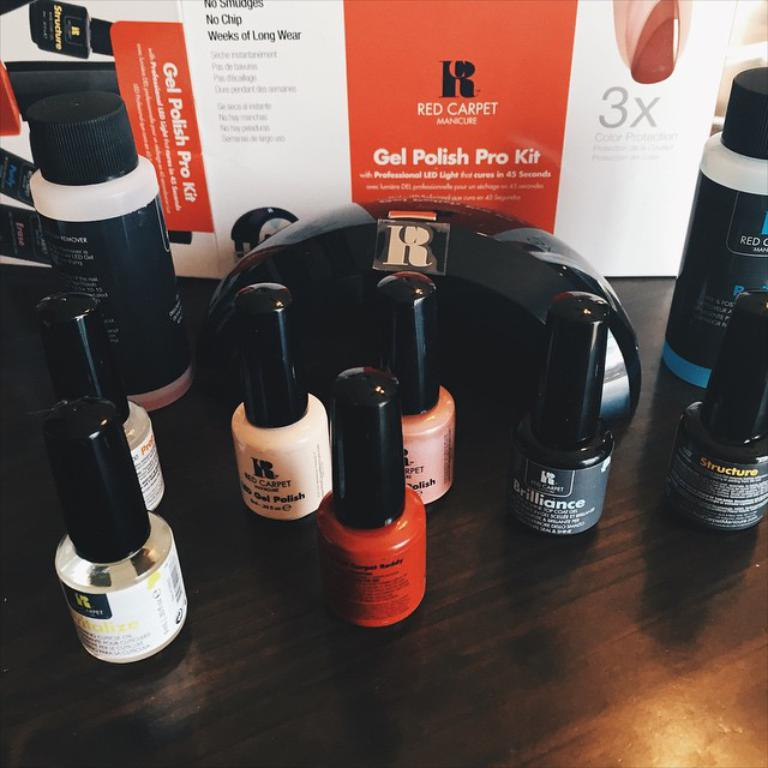<image>
Offer a succinct explanation of the picture presented. An assortment of nail polishes and a Gel Polish Pro Kit. 